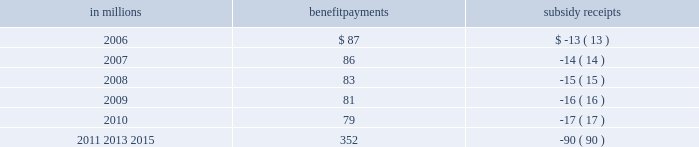At december 31 , 2005 , estimated total future post- retirement benefit payments , net of participant con- tributions and estimated future medicare part d subsidy receipts are as follows : in millions benefit payments subsidy receipts .
Non-u.s .
Postretirement benefits in addition to the u.s .
Plan , certain canadian and brazilian employees are eligible for retiree health care and life insurance .
Net postretirement benefit cost for our non-u.s .
Plans was $ 3 million for 2005 and $ 2 mil- lion for 2004 .
The benefit obligation for these plans was $ 21 million in 2005 and $ 20 million in 2004 .
Note 17 incentive plans international paper currently has a long-term in- centive compensation plan ( lticp ) that includes a stock option program , a restricted performance share program and a continuity award program , ad- ministered by a committee of nonemployee members of the board of directors ( committee ) who are not eligible for awards .
Also , stock appreciation rights ( sar 2019s ) have been awarded to employees of a non-u.s .
Subsidiary , with 5135 and 5435 rights outstanding at de- cember 31 , 2005 and 2004 , respectively .
We also have other performance-based restricted share/unit programs available to senior executives and directors .
International paper applies the provisions of apb opinion no .
25 , 201caccounting for stock issued to employees , 201d and related interpretations and the dis- closure provisions of sfas no .
123 , 201caccounting for stock-based compensation , 201d in accounting for our plans .
Sfas no .
123 ( r ) will be adopted effective jan- uary 1 , 2006 .
As no unvested stock options were out- standing at this date , the company believes that the adoption will not have a material impact on its con- solidated financial statements .
Stock option program international paper accounts for stock options using the intrinsic value method under apb opinion no .
25 .
Under this method , compensation expense is recorded over the related service period when the market price exceeds the option price at the measurement date , which is the grant date for international paper 2019s options .
No compensation expense is recorded as options are is- sued with an exercise price equal to the market price of international paper stock on the grant date .
During each reporting period , fully diluted earnings per share is calculated by assuming that 201cin-the-money 201d options are exercised and the exercise proceeds are used to repurchase shares in the marketplace .
When options are actually exercised , option proceeds are credited to equity and issued shares are included in the computation of earnings per common share , with no effect on re- ported earnings .
Equity is also increased by the tax benefit that international paper will receive in its tax return for income reported by the optionees in their in- dividual tax returns .
Under the program , officers and certain other em- ployees may be granted options to purchase interna- tional paper common stock .
The option price is the market price of the stock on the close of business on the day prior to the date of grant .
Options must be vested before they can be exercised .
Upon exercise of an op- tion , a replacement option may be granted under certain circumstances with an exercise price equal to the market price at the time of exercise and with a term extending to the expiration date of the original option .
The company discontinued its stock option pro- gram in 2004 for members of executive management , and in 2005 for all other eligible u.s .
And non-u.s .
Employees .
In the united states , the stock option pro- gram was replaced with a performance-based restricted share program for approximately 1250 employees to more closely tie long-term incentive compensation to company performance on two key performance drivers : return on investment ( roi ) and total shareholder re- turn ( tsr ) .
As part of this shift in focus away from stock options to performance-based restricted stock , the company accelerated the vesting of all 14 million un- vested stock options to july 12 , 2005 .
The company also considered the benefit to employees and the income statement impact in making its decision to accelerate the vesting of these options .
Based on the market value of the company 2019s common stock on july 12 , 2005 , the exercise prices of all such stock options were above the market value and , accordingly , the company recorded no expense as a result of this action. .
In 2006 what was the ratio of the benefit payments to the subsidy receipts? 
Computations: (87 / 13)
Answer: 6.69231. 